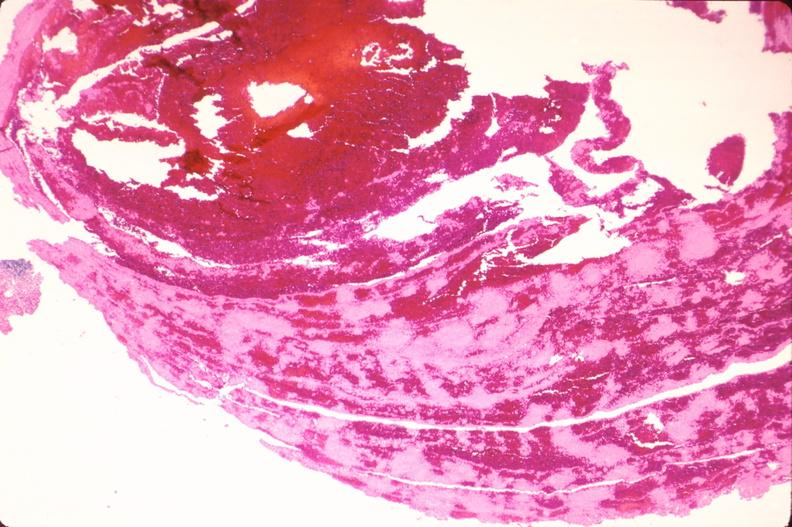s papillary intraductal adenocarcinoma present?
Answer the question using a single word or phrase. No 